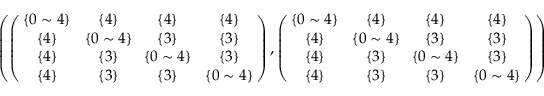<formula> <loc_0><loc_0><loc_500><loc_500>\begin{array} { r } { \left ( \left ( \, \begin{array} { c c c c } { \{ 0 \sim 4 \} } & { \{ 4 \} } & { \{ 4 \} } & { \{ 4 \} } \\ { \{ 4 \} } & { \, \{ 0 \sim 4 \} \, } & { \{ 3 \} } & { \{ 3 \} } \\ { \{ 4 \} } & { \{ 3 \} } & { \, \{ 0 \sim 4 \} \, } & { \{ 3 \} } \\ { \{ 4 \} } & { \{ 3 \} } & { \{ 3 \} } & { \{ 0 \sim 4 \} } \end{array} \, \right ) , \left ( \, \begin{array} { c c c c } { \{ 0 \sim 4 \} } & { \{ 4 \} } & { \{ 4 \} } & { \{ 4 \} } \\ { \{ 4 \} } & { \, \{ 0 \sim 4 \} \, } & { \{ 3 \} } & { \{ 3 \} } \\ { \{ 4 \} } & { \{ 3 \} } & { \, \{ 0 \sim 4 \} \, } & { \{ 3 \} } \\ { \{ 4 \} } & { \{ 3 \} } & { \{ 3 \} } & { \{ 0 \sim 4 \} } \end{array} \, \right ) \right ) } \end{array}</formula> 